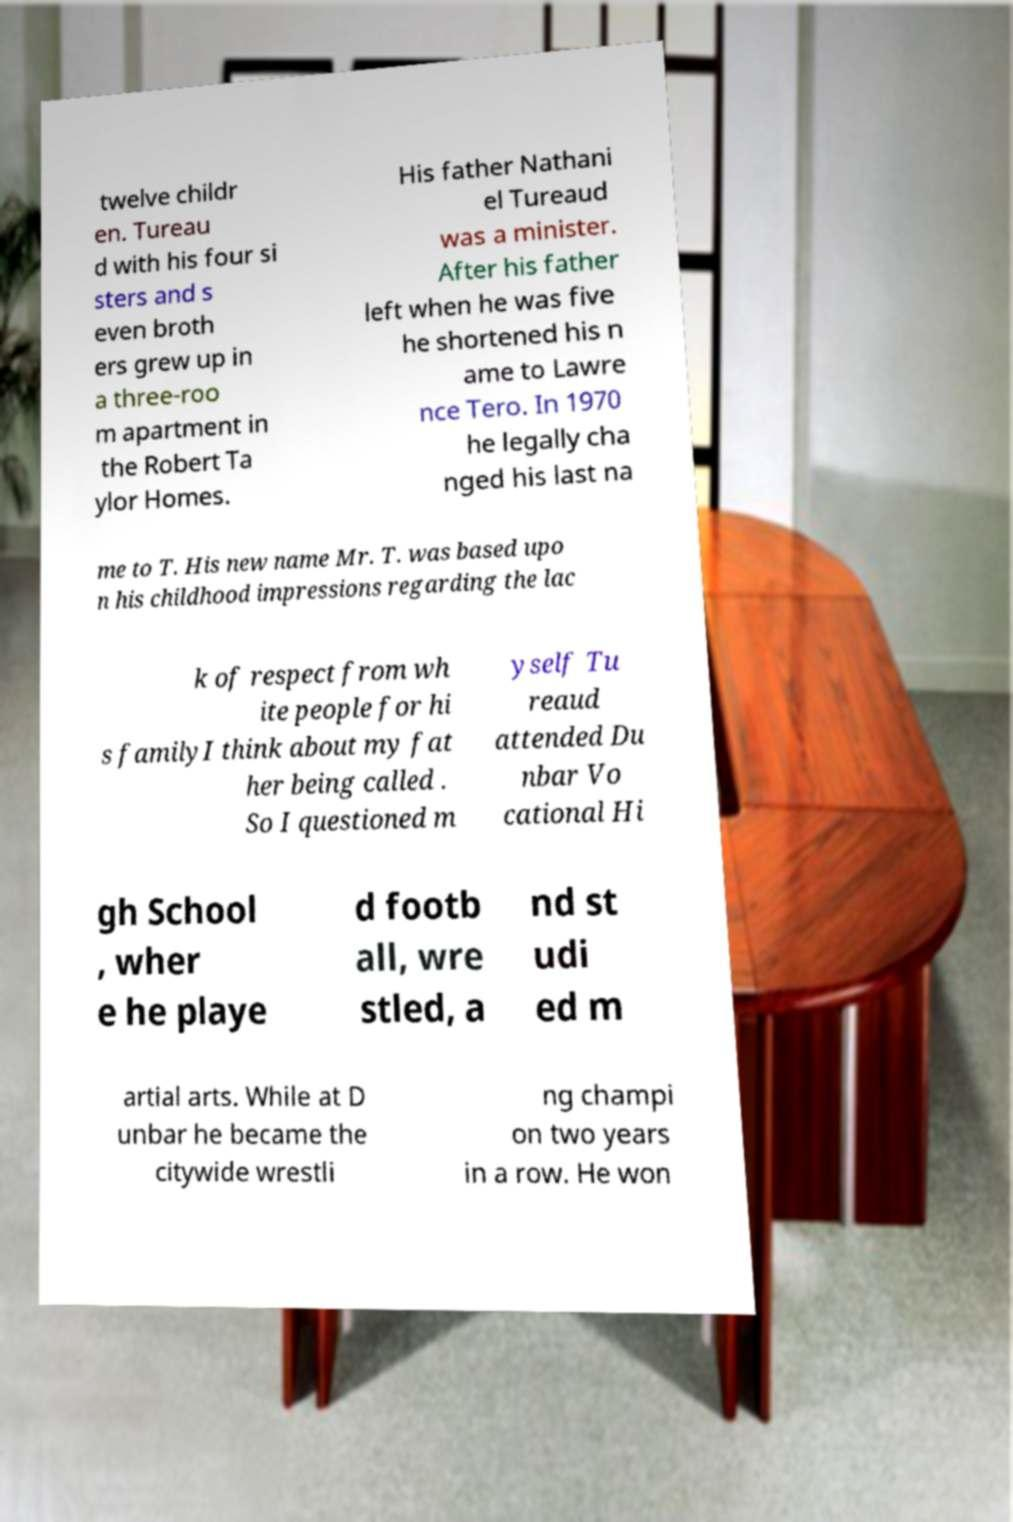I need the written content from this picture converted into text. Can you do that? twelve childr en. Tureau d with his four si sters and s even broth ers grew up in a three-roo m apartment in the Robert Ta ylor Homes. His father Nathani el Tureaud was a minister. After his father left when he was five he shortened his n ame to Lawre nce Tero. In 1970 he legally cha nged his last na me to T. His new name Mr. T. was based upo n his childhood impressions regarding the lac k of respect from wh ite people for hi s familyI think about my fat her being called . So I questioned m yself Tu reaud attended Du nbar Vo cational Hi gh School , wher e he playe d footb all, wre stled, a nd st udi ed m artial arts. While at D unbar he became the citywide wrestli ng champi on two years in a row. He won 